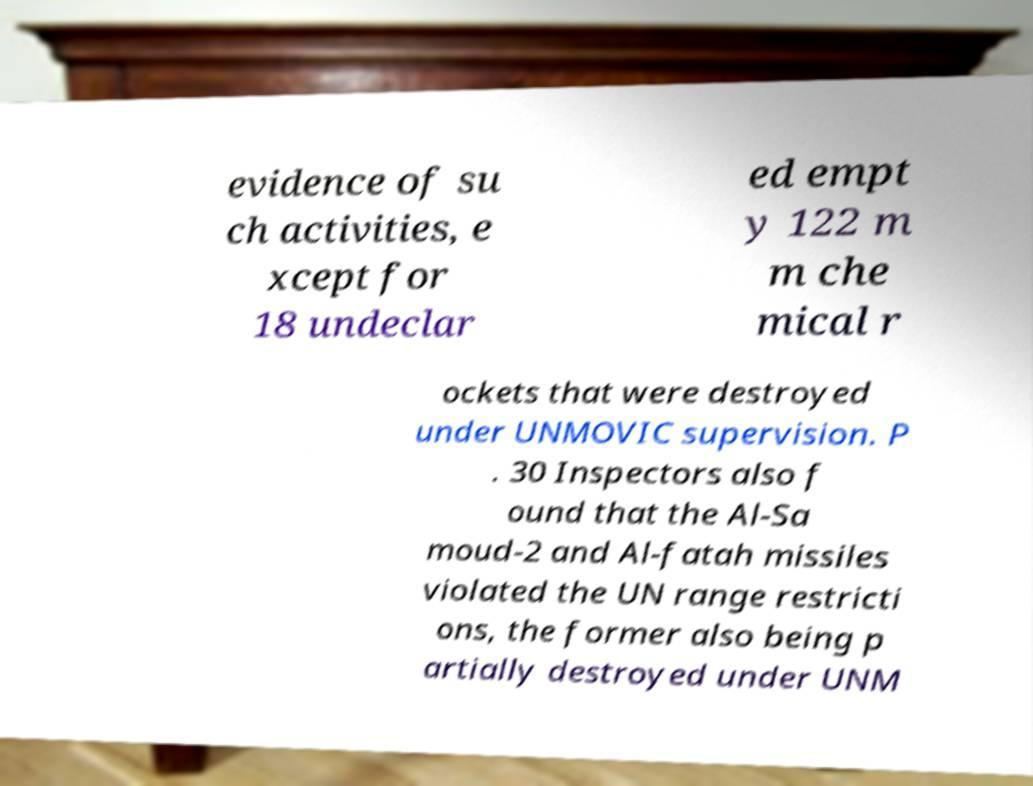I need the written content from this picture converted into text. Can you do that? evidence of su ch activities, e xcept for 18 undeclar ed empt y 122 m m che mical r ockets that were destroyed under UNMOVIC supervision. P . 30 Inspectors also f ound that the Al-Sa moud-2 and Al-fatah missiles violated the UN range restricti ons, the former also being p artially destroyed under UNM 